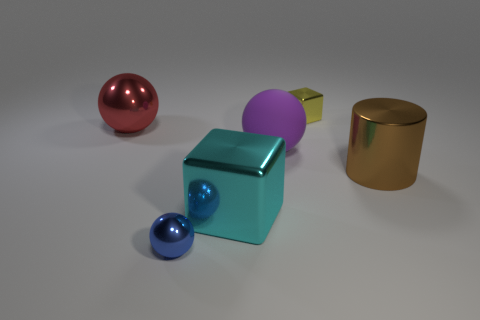Add 3 purple balls. How many objects exist? 9 Subtract all cylinders. How many objects are left? 5 Subtract all big objects. Subtract all cyan balls. How many objects are left? 2 Add 6 large brown metal cylinders. How many large brown metal cylinders are left? 7 Add 4 cyan blocks. How many cyan blocks exist? 5 Subtract 0 yellow spheres. How many objects are left? 6 